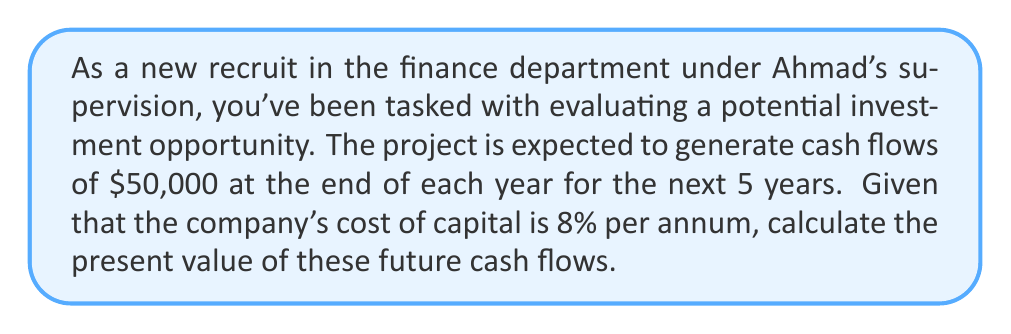Teach me how to tackle this problem. To compute the present value of future cash flows, we need to use the present value formula for an annuity, since we have equal cash flows over a fixed period.

The formula for the present value of an annuity is:

$$PV = C \times \frac{1 - (1 + r)^{-n}}{r}$$

Where:
$PV$ = Present Value
$C$ = Cash flow per period
$r$ = Discount rate (cost of capital)
$n$ = Number of periods

Given:
$C = \$50,000$
$r = 8\% = 0.08$
$n = 5$ years

Let's substitute these values into the formula:

$$PV = 50,000 \times \frac{1 - (1 + 0.08)^{-5}}{0.08}$$

Now, let's solve step by step:

1) First, calculate $(1 + 0.08)^{-5}$:
   $$(1.08)^{-5} = 0.6806$$

2) Subtract this from 1:
   $$1 - 0.6806 = 0.3194$$

3) Divide by 0.08:
   $$\frac{0.3194}{0.08} = 3.9925$$

4) Multiply by 50,000:
   $$50,000 \times 3.9925 = 199,625$$

Therefore, the present value of the future cash flows is $199,625.
Answer: $199,625 